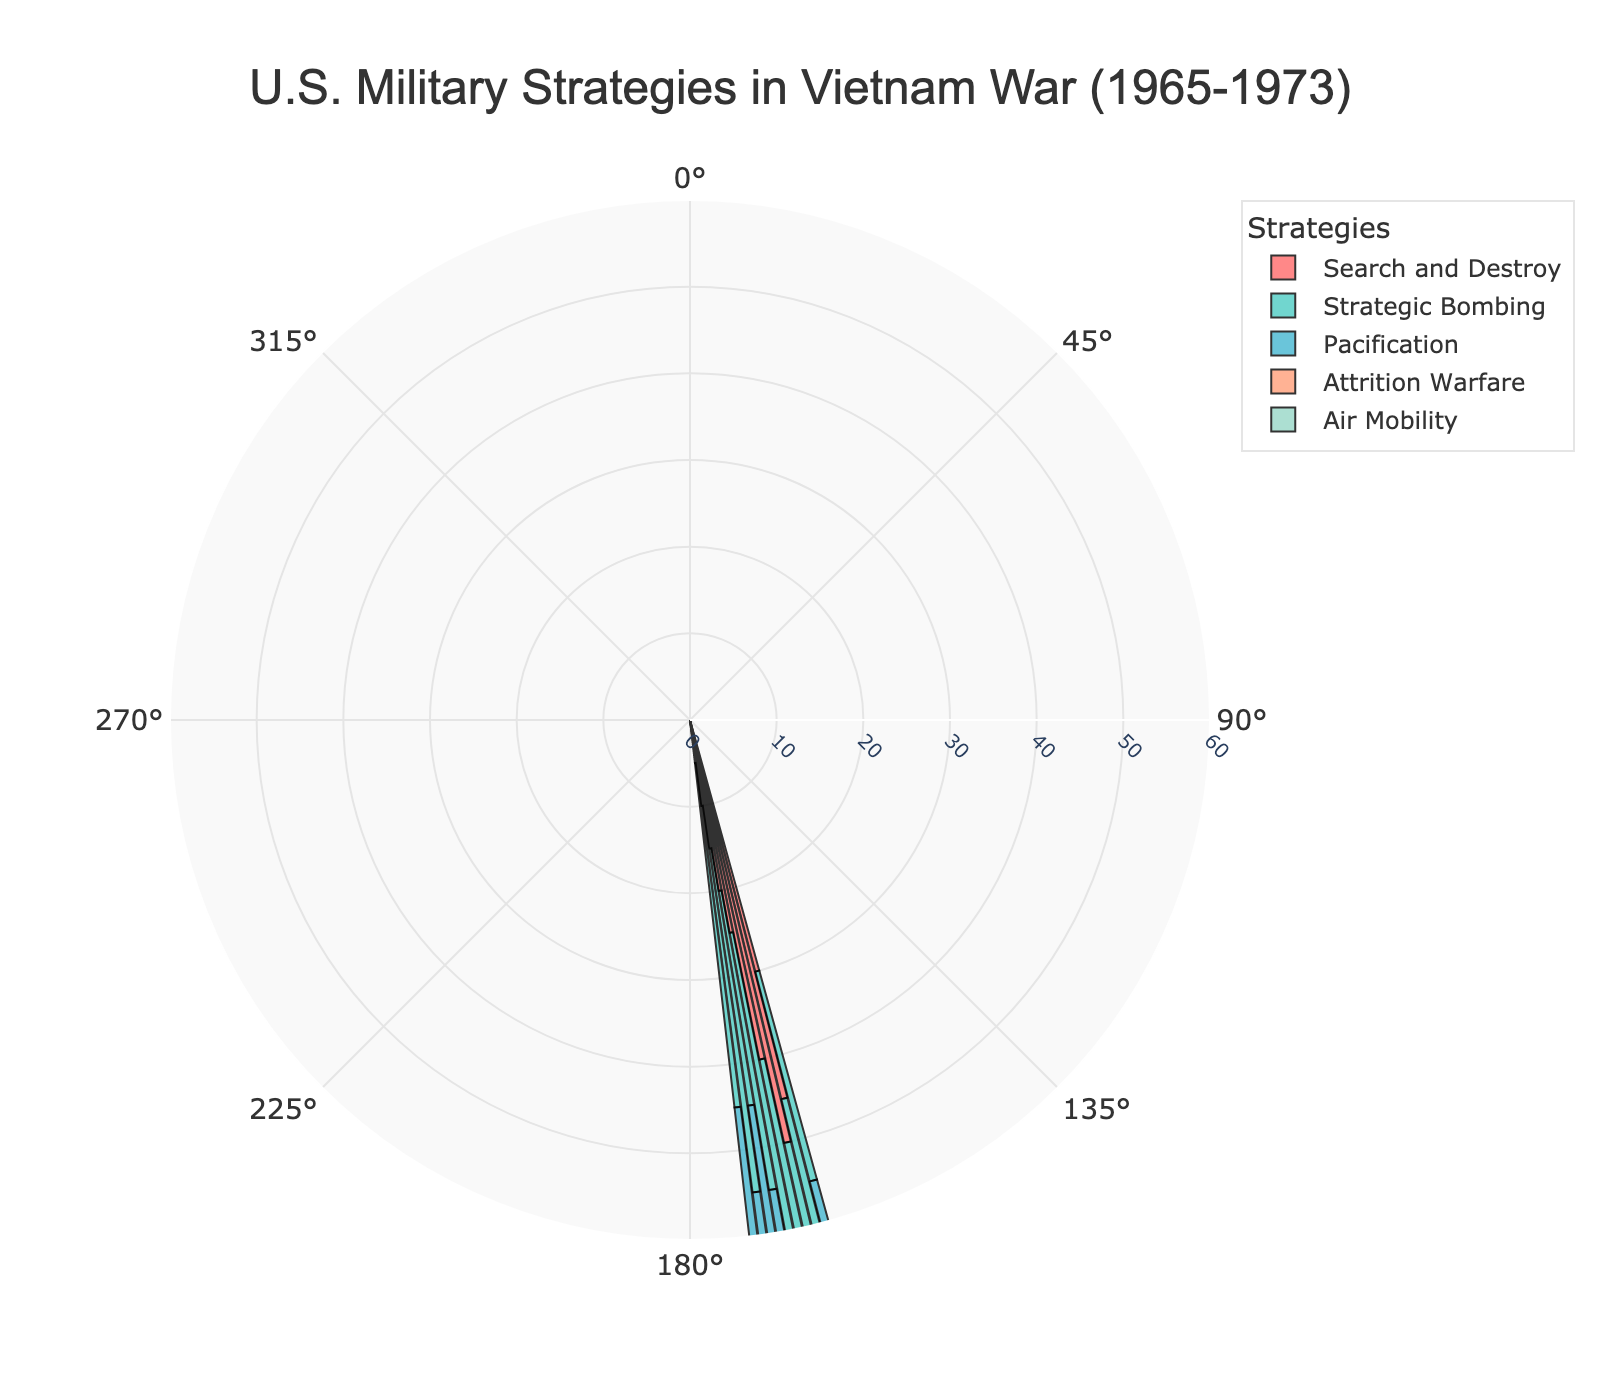What is the title of the figure? The title is usually located at the top of the figure and serves as the main descriptor of the chart's content.
Answer: U.S. Military Strategies in Vietnam War (1965-1973) How many unique strategies are depicted in the figure? The legend or the different colored sections of the rose chart will indicate the number of unique strategies. Each strategy will have a distinct color.
Answer: 5 Which strategy had the highest frequency in 1967? By examining the length of the bars in the section corresponding to 1967, the strategy with the longest bar indicates the highest frequency.
Answer: Search and Destroy How does the frequency of "Strategic Bombing" in 1972 compare to 1965? Compare the bar lengths for "Strategic Bombing" in both years. The longer bar indicates a higher frequency.
Answer: Higher in 1972 Which year shows the highest frequency for "Pacification"? Check the lengths of the bars corresponding to "Pacification" across all years. The longest bar indicates the highest frequency.
Answer: 1971 What is the combined frequency of "Air Mobility" in 1965 and 1973? Add the frequencies of "Air Mobility" for the years 1965 and 1973, as indicated by the lengths of the bars for these years.
Answer: 35 In which year was "Attrition Warfare" implemented the least? Locate the smallest bar corresponding to "Attrition Warfare" across all years to find the year with the least implementation.
Answer: 1973 How did the frequency of "Search and Destroy" change from 1969 to 1970? Observe the differences in bar lengths for "Search and Destroy" between 1969 and 1970. The change is the difference in these lengths.
Answer: Decreased What was the average frequency of "Strategic Bombing" over the entire period? Add the frequencies of "Strategic Bombing" for all years and divide by the number of years (9) to find the average.
Answer: 36.1 What was the trend of "Pacification" strategy from 1965 to 1973? Look at the change in bar lengths for "Pacification" from 1965 to 1973. Note whether the bar lengths generally increase, decrease, or stay constant.
Answer: Generally increasing 